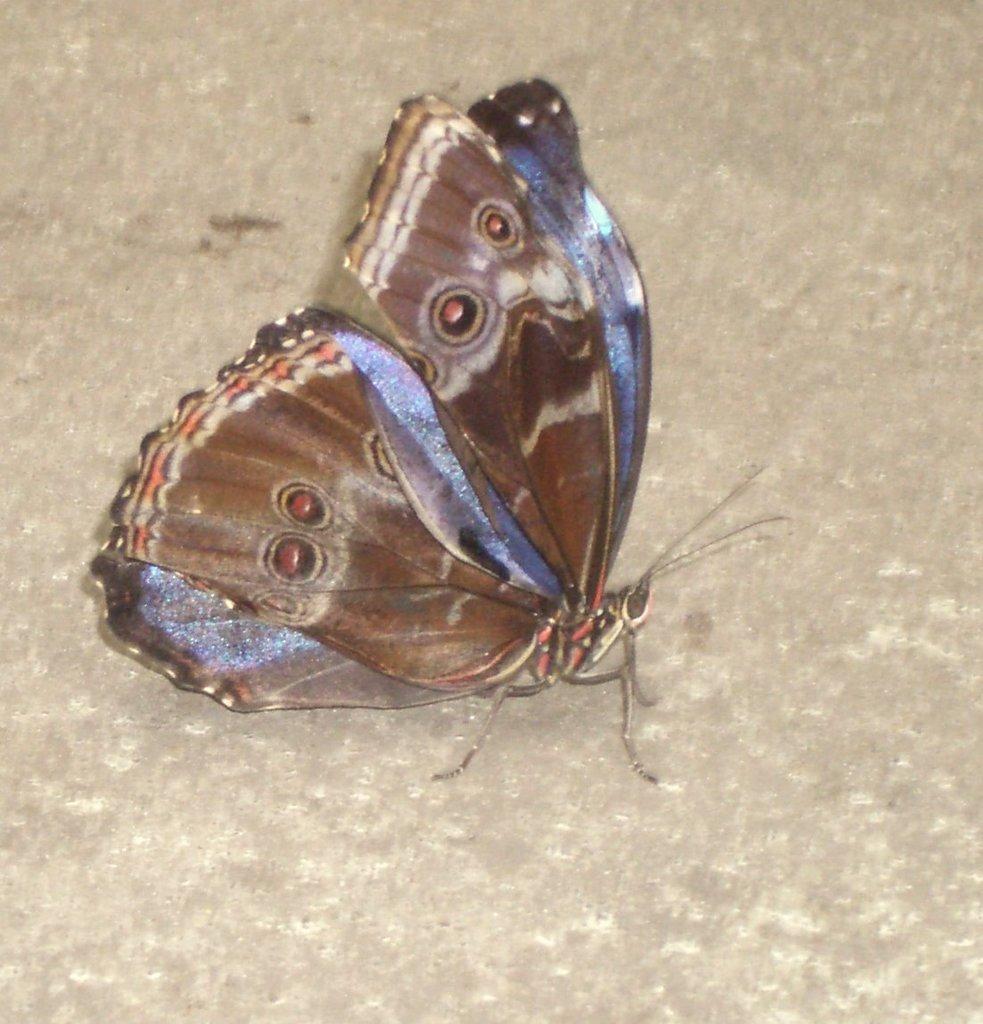Could you give a brief overview of what you see in this image? In this image we can see a butterfly. A butterfly is in multiple colors. 